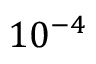<formula> <loc_0><loc_0><loc_500><loc_500>1 0 ^ { - 4 }</formula> 